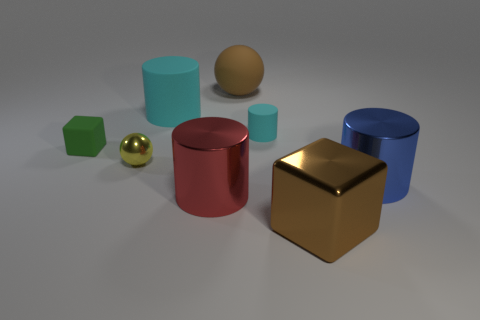What number of other things are there of the same material as the small yellow sphere
Your answer should be very brief. 3. There is a large brown object that is behind the big blue shiny object behind the shiny cylinder left of the small matte cylinder; what is its material?
Provide a short and direct response. Rubber. Is the green cube made of the same material as the large blue thing?
Provide a short and direct response. No. How many cylinders are large brown rubber things or big cyan matte things?
Ensure brevity in your answer.  1. What is the color of the tiny matte thing on the right side of the rubber block?
Your answer should be very brief. Cyan. How many shiny things are either small gray things or big spheres?
Provide a short and direct response. 0. What is the material of the ball that is to the right of the big red metal object in front of the large blue thing?
Your answer should be compact. Rubber. There is a block that is the same color as the big rubber ball; what is it made of?
Keep it short and to the point. Metal. The small metal sphere is what color?
Give a very brief answer. Yellow. There is a tiny object behind the small green matte block; are there any big red shiny objects on the left side of it?
Keep it short and to the point. Yes. 